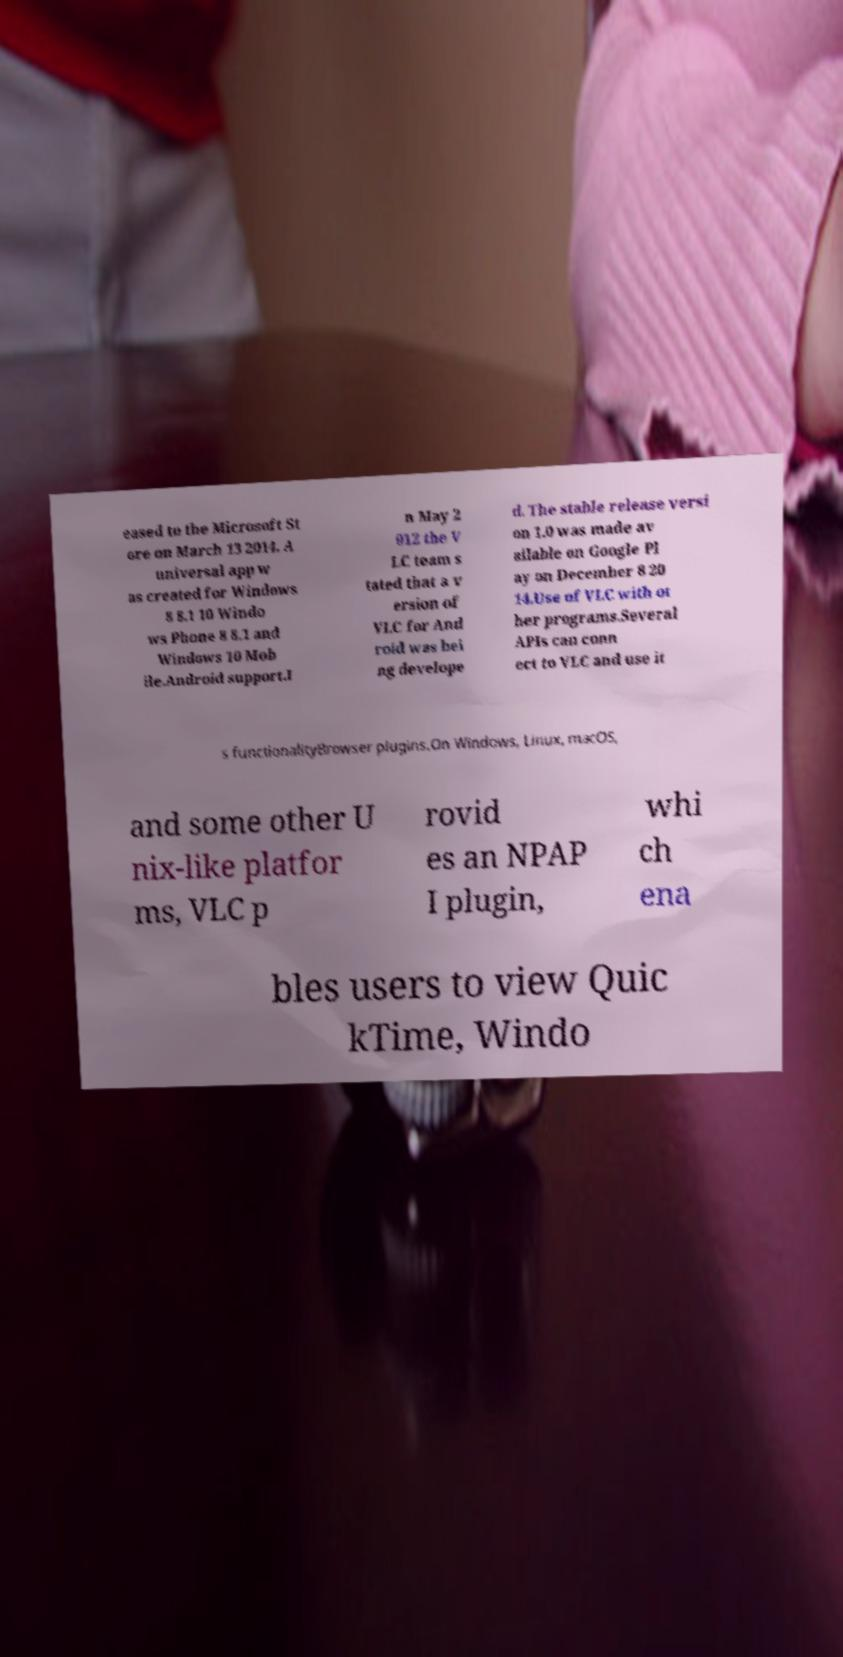Can you read and provide the text displayed in the image?This photo seems to have some interesting text. Can you extract and type it out for me? eased to the Microsoft St ore on March 13 2014. A universal app w as created for Windows 8 8.1 10 Windo ws Phone 8 8.1 and Windows 10 Mob ile.Android support.I n May 2 012 the V LC team s tated that a v ersion of VLC for And roid was bei ng develope d. The stable release versi on 1.0 was made av ailable on Google Pl ay on December 8 20 14.Use of VLC with ot her programs.Several APIs can conn ect to VLC and use it s functionalityBrowser plugins.On Windows, Linux, macOS, and some other U nix-like platfor ms, VLC p rovid es an NPAP I plugin, whi ch ena bles users to view Quic kTime, Windo 